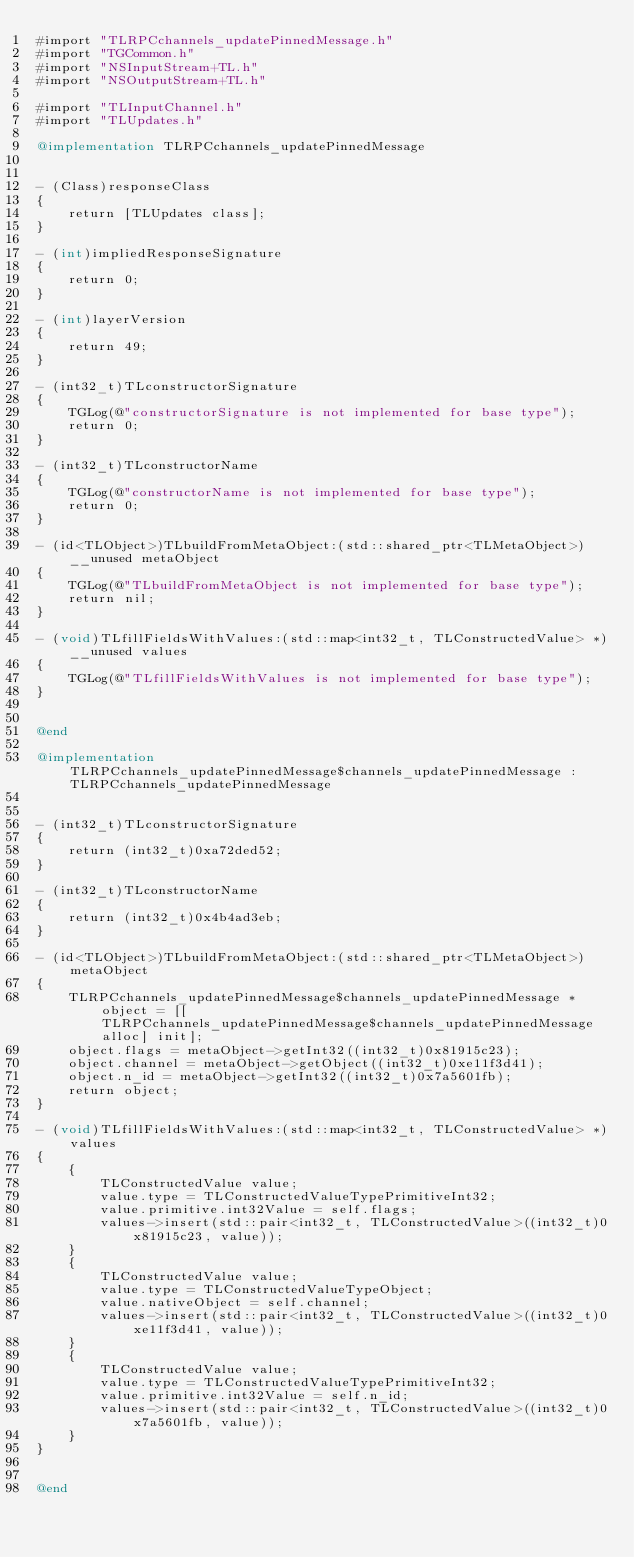<code> <loc_0><loc_0><loc_500><loc_500><_ObjectiveC_>#import "TLRPCchannels_updatePinnedMessage.h"
#import "TGCommon.h"
#import "NSInputStream+TL.h"
#import "NSOutputStream+TL.h"

#import "TLInputChannel.h"
#import "TLUpdates.h"

@implementation TLRPCchannels_updatePinnedMessage


- (Class)responseClass
{
    return [TLUpdates class];
}

- (int)impliedResponseSignature
{
    return 0;
}

- (int)layerVersion
{
    return 49;
}

- (int32_t)TLconstructorSignature
{
    TGLog(@"constructorSignature is not implemented for base type");
    return 0;
}

- (int32_t)TLconstructorName
{
    TGLog(@"constructorName is not implemented for base type");
    return 0;
}

- (id<TLObject>)TLbuildFromMetaObject:(std::shared_ptr<TLMetaObject>)__unused metaObject
{
    TGLog(@"TLbuildFromMetaObject is not implemented for base type");
    return nil;
}

- (void)TLfillFieldsWithValues:(std::map<int32_t, TLConstructedValue> *)__unused values
{
    TGLog(@"TLfillFieldsWithValues is not implemented for base type");
}


@end

@implementation TLRPCchannels_updatePinnedMessage$channels_updatePinnedMessage : TLRPCchannels_updatePinnedMessage


- (int32_t)TLconstructorSignature
{
    return (int32_t)0xa72ded52;
}

- (int32_t)TLconstructorName
{
    return (int32_t)0x4b4ad3eb;
}

- (id<TLObject>)TLbuildFromMetaObject:(std::shared_ptr<TLMetaObject>)metaObject
{
    TLRPCchannels_updatePinnedMessage$channels_updatePinnedMessage *object = [[TLRPCchannels_updatePinnedMessage$channels_updatePinnedMessage alloc] init];
    object.flags = metaObject->getInt32((int32_t)0x81915c23);
    object.channel = metaObject->getObject((int32_t)0xe11f3d41);
    object.n_id = metaObject->getInt32((int32_t)0x7a5601fb);
    return object;
}

- (void)TLfillFieldsWithValues:(std::map<int32_t, TLConstructedValue> *)values
{
    {
        TLConstructedValue value;
        value.type = TLConstructedValueTypePrimitiveInt32;
        value.primitive.int32Value = self.flags;
        values->insert(std::pair<int32_t, TLConstructedValue>((int32_t)0x81915c23, value));
    }
    {
        TLConstructedValue value;
        value.type = TLConstructedValueTypeObject;
        value.nativeObject = self.channel;
        values->insert(std::pair<int32_t, TLConstructedValue>((int32_t)0xe11f3d41, value));
    }
    {
        TLConstructedValue value;
        value.type = TLConstructedValueTypePrimitiveInt32;
        value.primitive.int32Value = self.n_id;
        values->insert(std::pair<int32_t, TLConstructedValue>((int32_t)0x7a5601fb, value));
    }
}


@end

</code> 